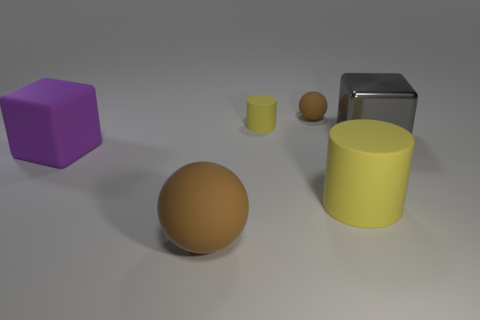Subtract all red balls. How many purple cubes are left? 1 Add 1 brown spheres. How many objects exist? 7 Subtract all spheres. How many objects are left? 4 Subtract 1 cylinders. How many cylinders are left? 1 Subtract all brown cylinders. Subtract all yellow cubes. How many cylinders are left? 2 Subtract all big brown cylinders. Subtract all cylinders. How many objects are left? 4 Add 6 big gray metal objects. How many big gray metal objects are left? 7 Add 1 large metallic things. How many large metallic things exist? 2 Subtract 1 brown spheres. How many objects are left? 5 